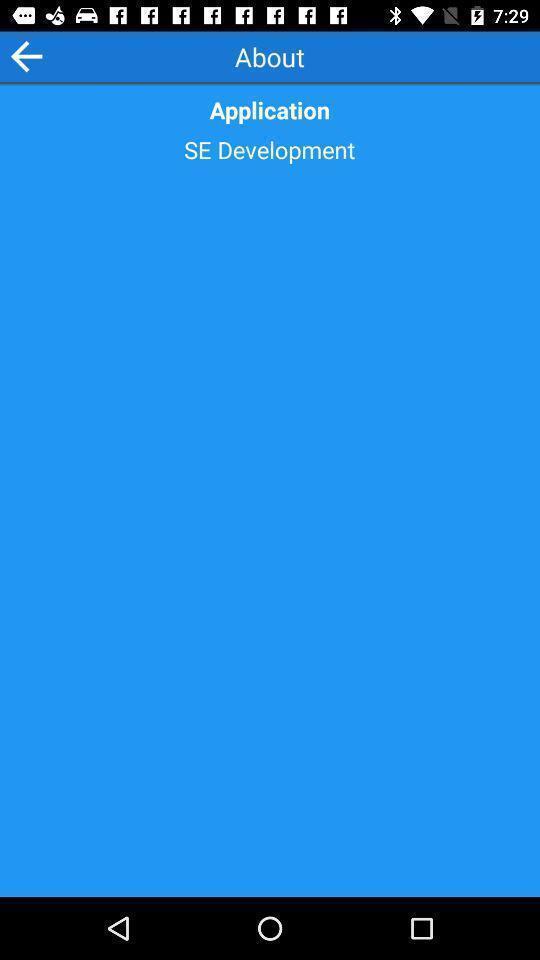Provide a description of this screenshot. Screen page about dictionary app. 